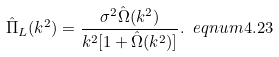<formula> <loc_0><loc_0><loc_500><loc_500>\hat { \Pi } _ { L } ( k ^ { 2 } ) = \frac { \sigma ^ { 2 } \hat { \Omega } ( k ^ { 2 } ) } { k ^ { 2 } [ 1 + \hat { \Omega } ( k ^ { 2 } ) ] } . \ e q n u m { 4 . 2 3 }</formula> 